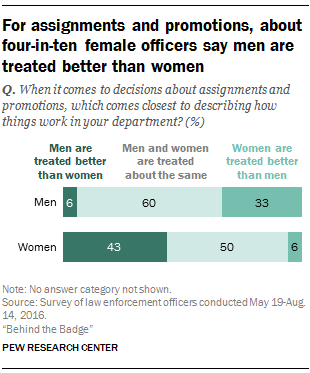Identify some key points in this picture. The difference in how men and women are treated when choosing is determined by whether men and women are treated the same between them, with a value of 0.1. The chart shows that men and women are generally treated the same in terms of what they select. 